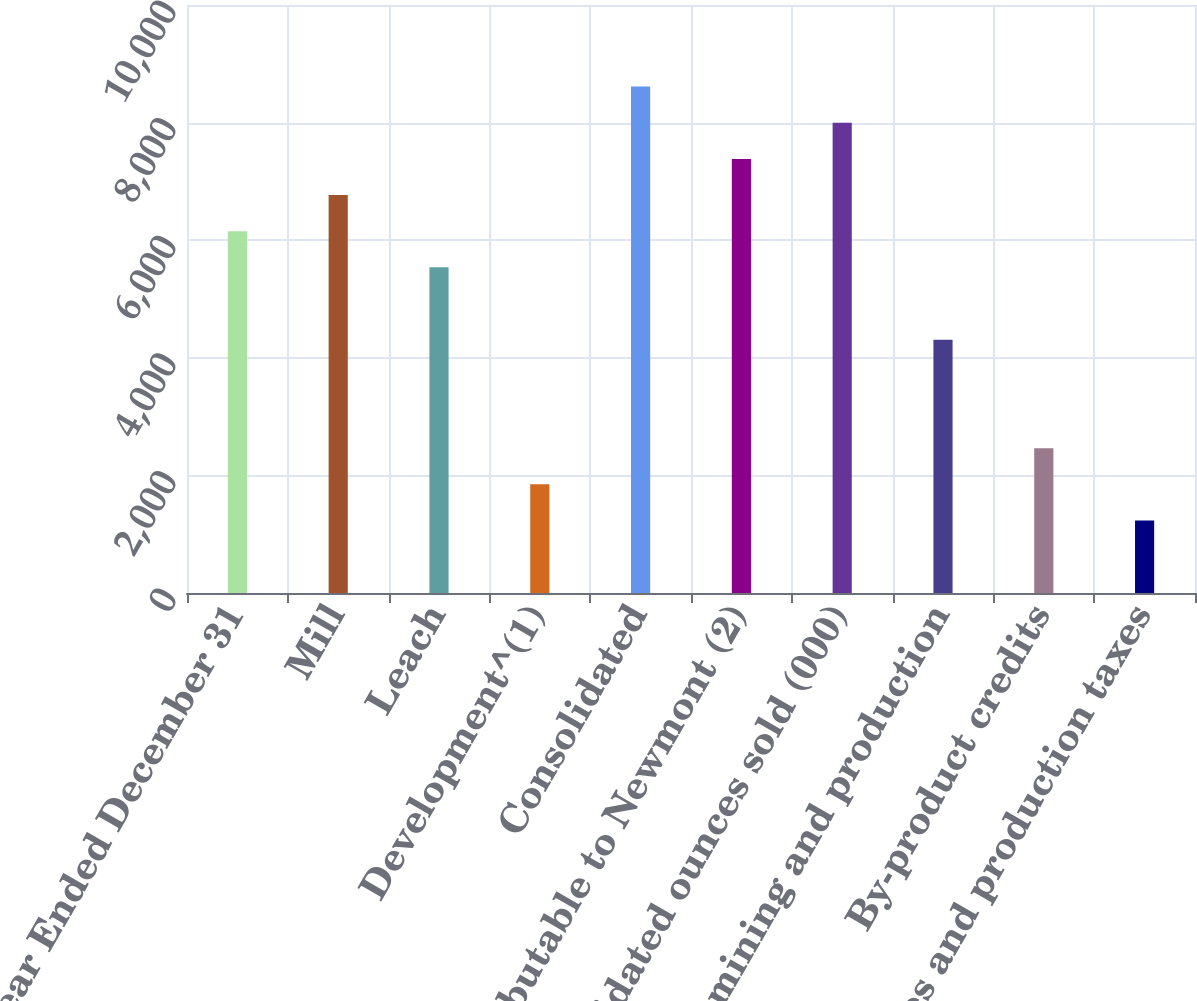Convert chart. <chart><loc_0><loc_0><loc_500><loc_500><bar_chart><fcel>Year Ended December 31<fcel>Mill<fcel>Leach<fcel>Development^(1)<fcel>Consolidated<fcel>Attributable to Newmont (2)<fcel>Consolidated ounces sold (000)<fcel>Direct mining and production<fcel>By-product credits<fcel>Royalties and production taxes<nl><fcel>6153<fcel>6767.9<fcel>5538.1<fcel>1848.7<fcel>8612.6<fcel>7382.8<fcel>7997.7<fcel>4308.3<fcel>2463.6<fcel>1233.8<nl></chart> 